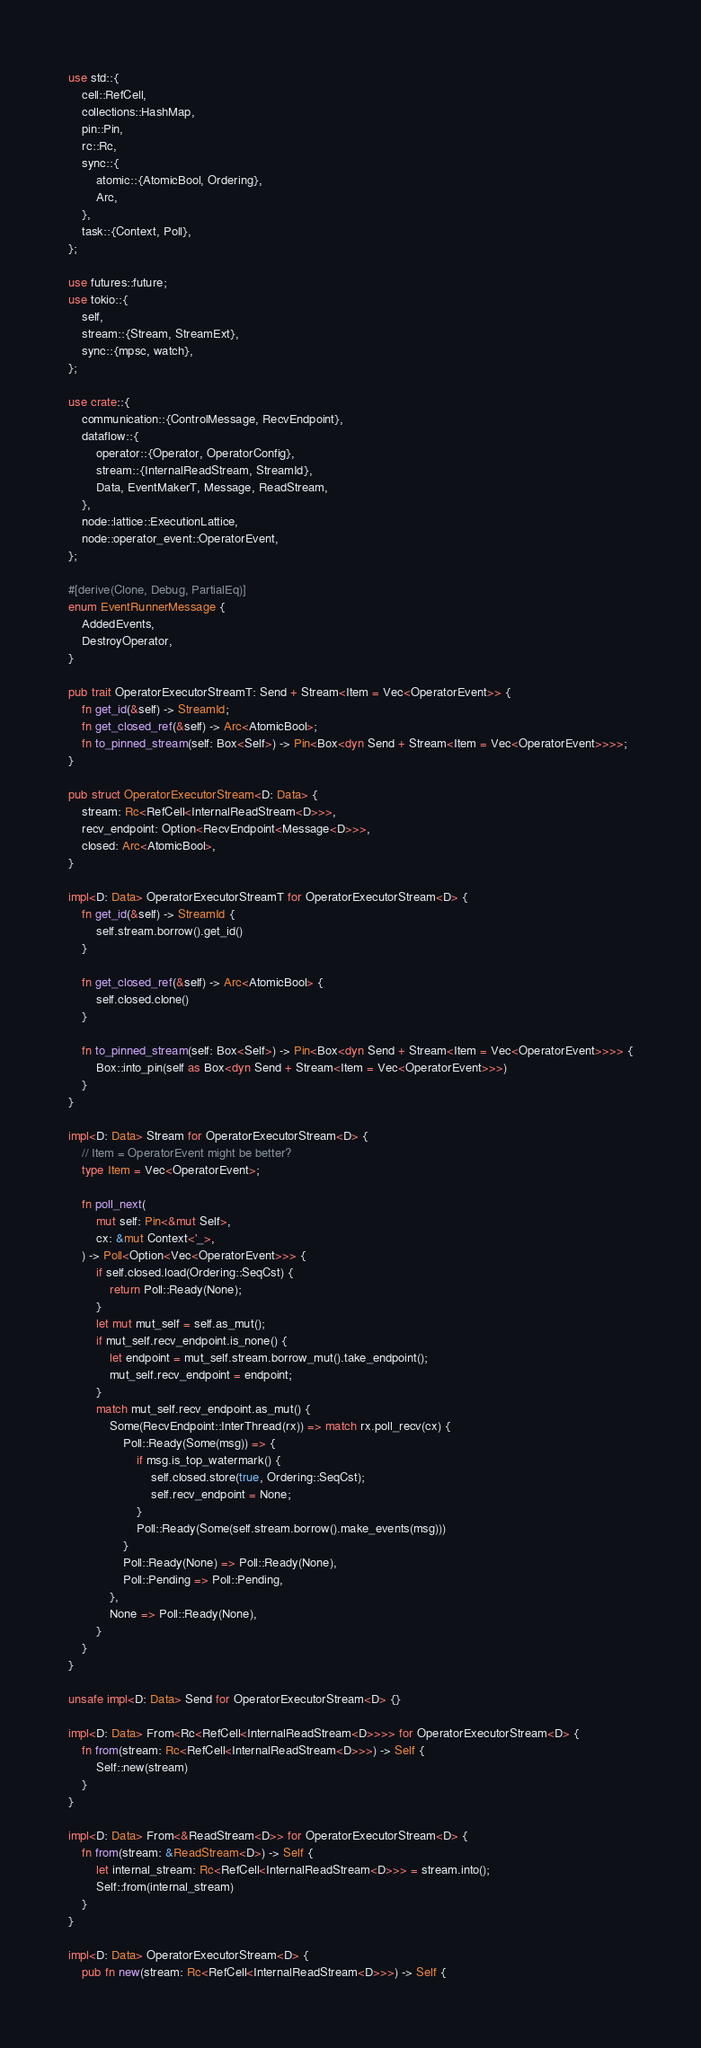<code> <loc_0><loc_0><loc_500><loc_500><_Rust_>use std::{
    cell::RefCell,
    collections::HashMap,
    pin::Pin,
    rc::Rc,
    sync::{
        atomic::{AtomicBool, Ordering},
        Arc,
    },
    task::{Context, Poll},
};

use futures::future;
use tokio::{
    self,
    stream::{Stream, StreamExt},
    sync::{mpsc, watch},
};

use crate::{
    communication::{ControlMessage, RecvEndpoint},
    dataflow::{
        operator::{Operator, OperatorConfig},
        stream::{InternalReadStream, StreamId},
        Data, EventMakerT, Message, ReadStream,
    },
    node::lattice::ExecutionLattice,
    node::operator_event::OperatorEvent,
};

#[derive(Clone, Debug, PartialEq)]
enum EventRunnerMessage {
    AddedEvents,
    DestroyOperator,
}

pub trait OperatorExecutorStreamT: Send + Stream<Item = Vec<OperatorEvent>> {
    fn get_id(&self) -> StreamId;
    fn get_closed_ref(&self) -> Arc<AtomicBool>;
    fn to_pinned_stream(self: Box<Self>) -> Pin<Box<dyn Send + Stream<Item = Vec<OperatorEvent>>>>;
}

pub struct OperatorExecutorStream<D: Data> {
    stream: Rc<RefCell<InternalReadStream<D>>>,
    recv_endpoint: Option<RecvEndpoint<Message<D>>>,
    closed: Arc<AtomicBool>,
}

impl<D: Data> OperatorExecutorStreamT for OperatorExecutorStream<D> {
    fn get_id(&self) -> StreamId {
        self.stream.borrow().get_id()
    }

    fn get_closed_ref(&self) -> Arc<AtomicBool> {
        self.closed.clone()
    }

    fn to_pinned_stream(self: Box<Self>) -> Pin<Box<dyn Send + Stream<Item = Vec<OperatorEvent>>>> {
        Box::into_pin(self as Box<dyn Send + Stream<Item = Vec<OperatorEvent>>>)
    }
}

impl<D: Data> Stream for OperatorExecutorStream<D> {
    // Item = OperatorEvent might be better?
    type Item = Vec<OperatorEvent>;

    fn poll_next(
        mut self: Pin<&mut Self>,
        cx: &mut Context<'_>,
    ) -> Poll<Option<Vec<OperatorEvent>>> {
        if self.closed.load(Ordering::SeqCst) {
            return Poll::Ready(None);
        }
        let mut mut_self = self.as_mut();
        if mut_self.recv_endpoint.is_none() {
            let endpoint = mut_self.stream.borrow_mut().take_endpoint();
            mut_self.recv_endpoint = endpoint;
        }
        match mut_self.recv_endpoint.as_mut() {
            Some(RecvEndpoint::InterThread(rx)) => match rx.poll_recv(cx) {
                Poll::Ready(Some(msg)) => {
                    if msg.is_top_watermark() {
                        self.closed.store(true, Ordering::SeqCst);
                        self.recv_endpoint = None;
                    }
                    Poll::Ready(Some(self.stream.borrow().make_events(msg)))
                }
                Poll::Ready(None) => Poll::Ready(None),
                Poll::Pending => Poll::Pending,
            },
            None => Poll::Ready(None),
        }
    }
}

unsafe impl<D: Data> Send for OperatorExecutorStream<D> {}

impl<D: Data> From<Rc<RefCell<InternalReadStream<D>>>> for OperatorExecutorStream<D> {
    fn from(stream: Rc<RefCell<InternalReadStream<D>>>) -> Self {
        Self::new(stream)
    }
}

impl<D: Data> From<&ReadStream<D>> for OperatorExecutorStream<D> {
    fn from(stream: &ReadStream<D>) -> Self {
        let internal_stream: Rc<RefCell<InternalReadStream<D>>> = stream.into();
        Self::from(internal_stream)
    }
}

impl<D: Data> OperatorExecutorStream<D> {
    pub fn new(stream: Rc<RefCell<InternalReadStream<D>>>) -> Self {</code> 